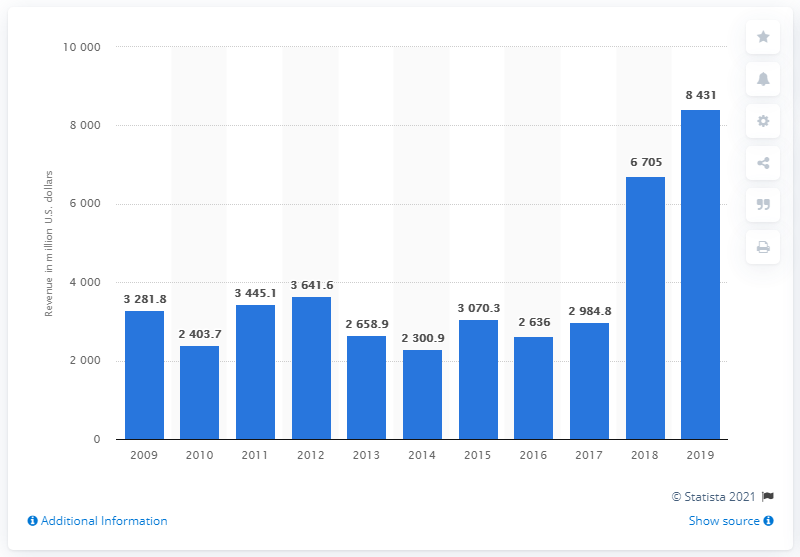Specify some key components in this picture. In 2019, McDermott International had a revenue of 8,431. 